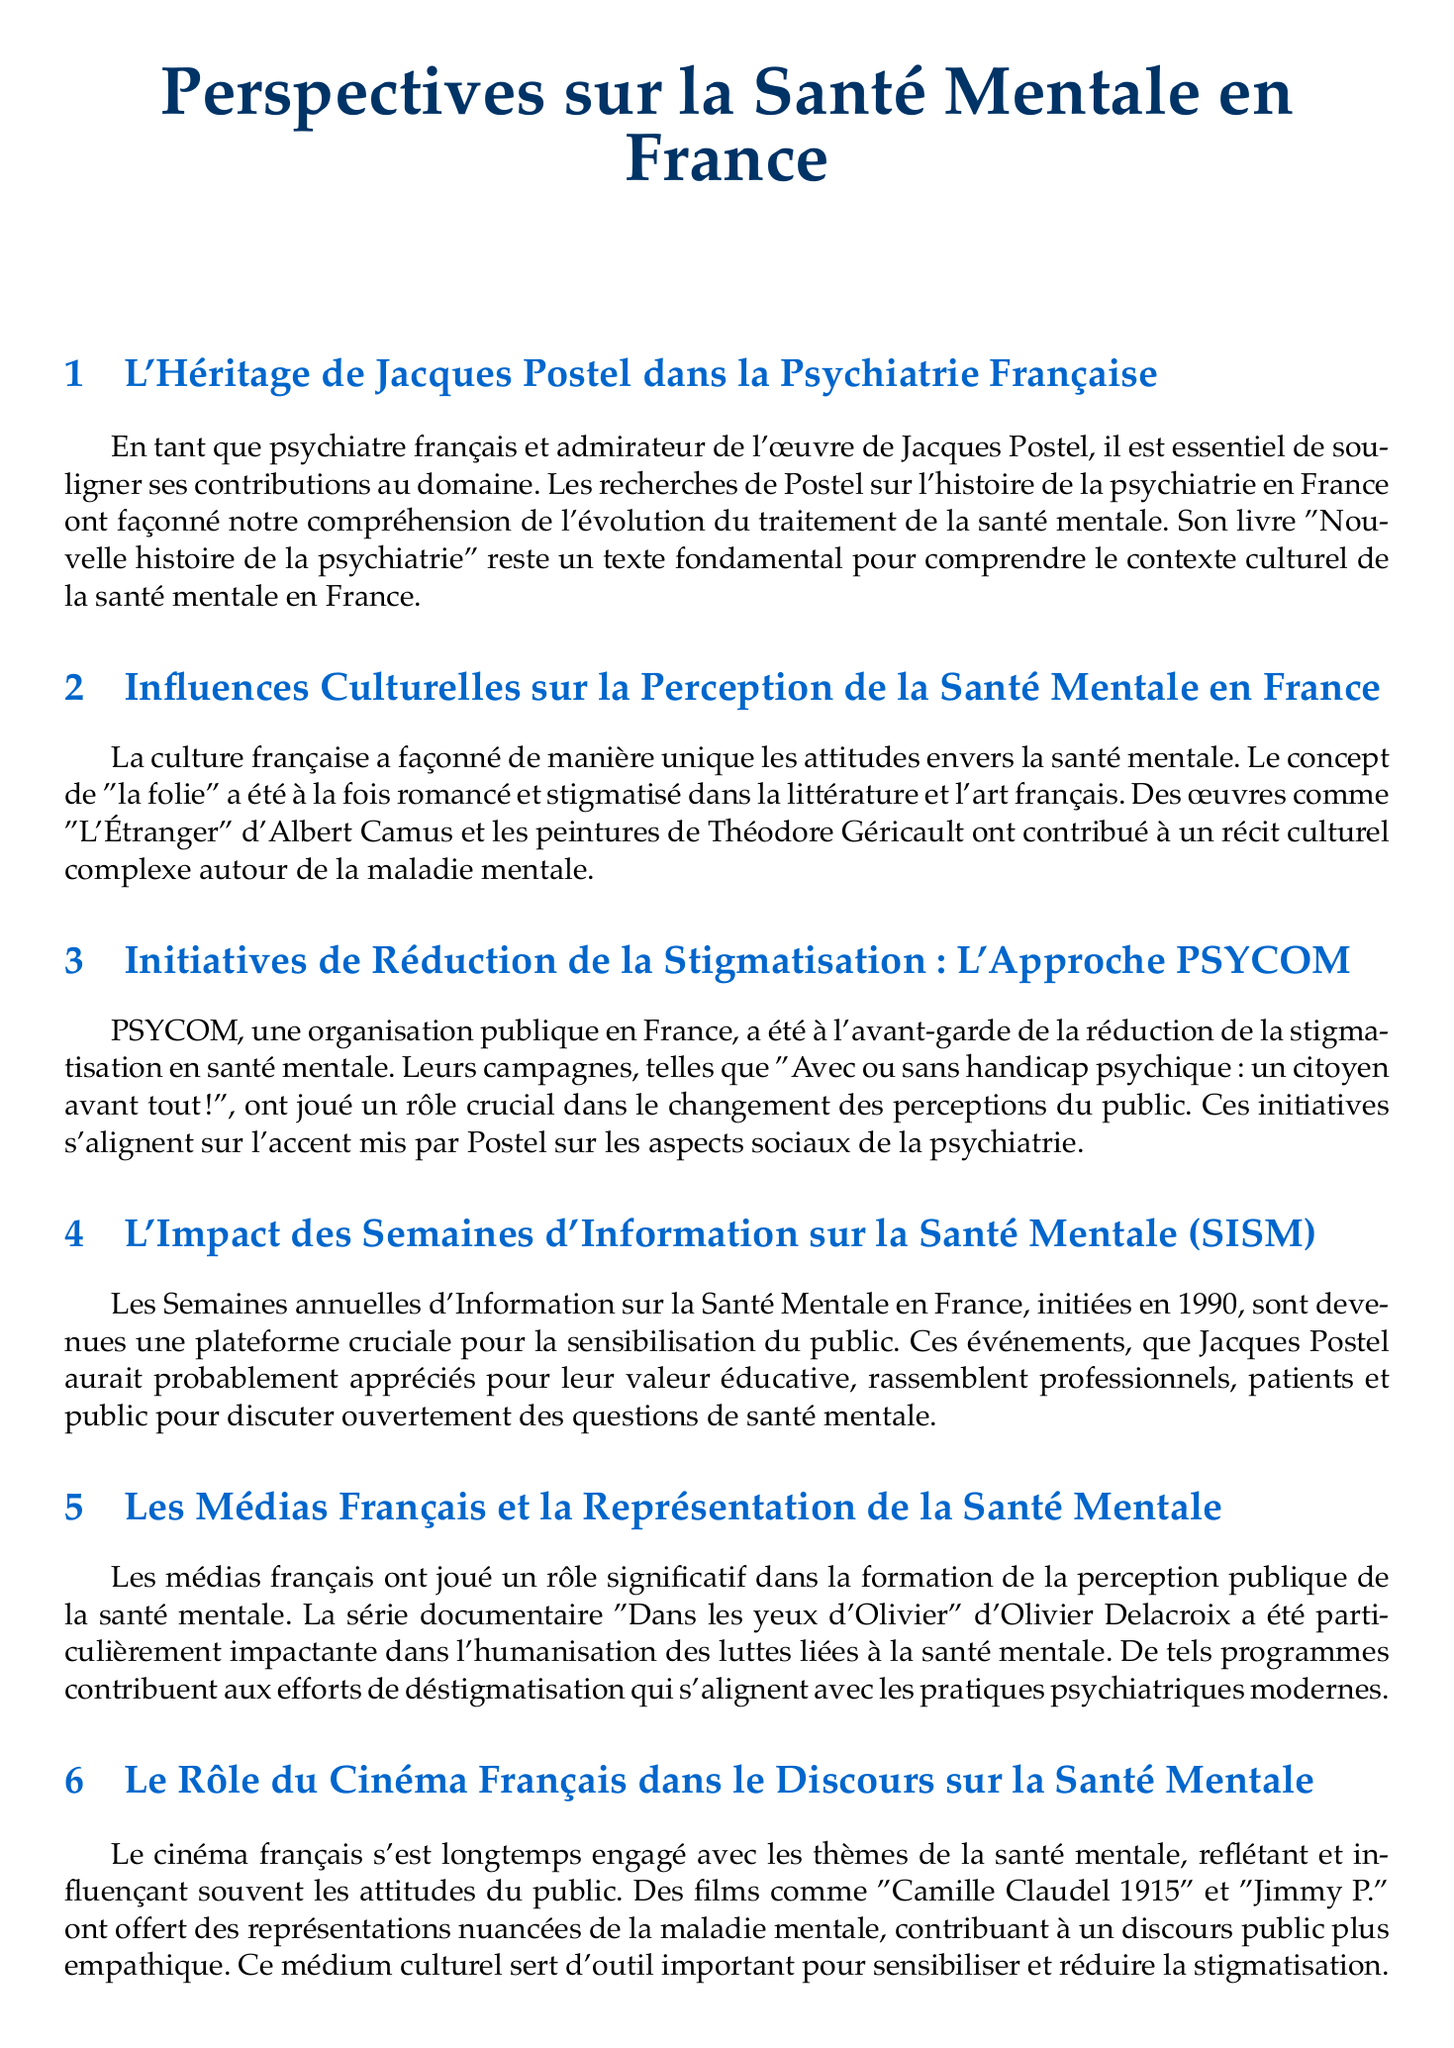What is the title of Jacques Postel's book? The title is stated in the section about his legacy in French psychiatry.
Answer: Nouvelle histoire de la psychiatrie What year were the Mental Health Information Weeks (SISM) initiated? The year is mentioned in the section discussing the impact of SISM.
Answer: 1990 What is the name of the documentary series by Olivier Delacroix? This title is specifically mentioned in the section on French media and mental health representation.
Answer: Dans les yeux d'Olivier Which initiative is located in Paris? The location is highlighted in the section discussing innovative approaches to mental health support.
Answer: Maison Perchée What cultural medium serves as a tool for raising awareness and reducing stigma? The cultural medium is identified in the section on the role of French cinema.
Answer: Cinema Which philosophical tradition influenced psychiatric thought according to the document? This tradition is discussed in the final section regarding the influence of French philosophers.
Answer: Existentialism What campaign does PSYCOM promote for stigma reduction? The name of the campaign is provided in the section about the PSYCOM approach.
Answer: Avec ou sans handicap psychique : un citoyen avant tout ! What is a central theme reflected in French cinema as per the document? This theme is discussed in the section regarding the role of French cinema in mental health discourse.
Answer: Mental health 